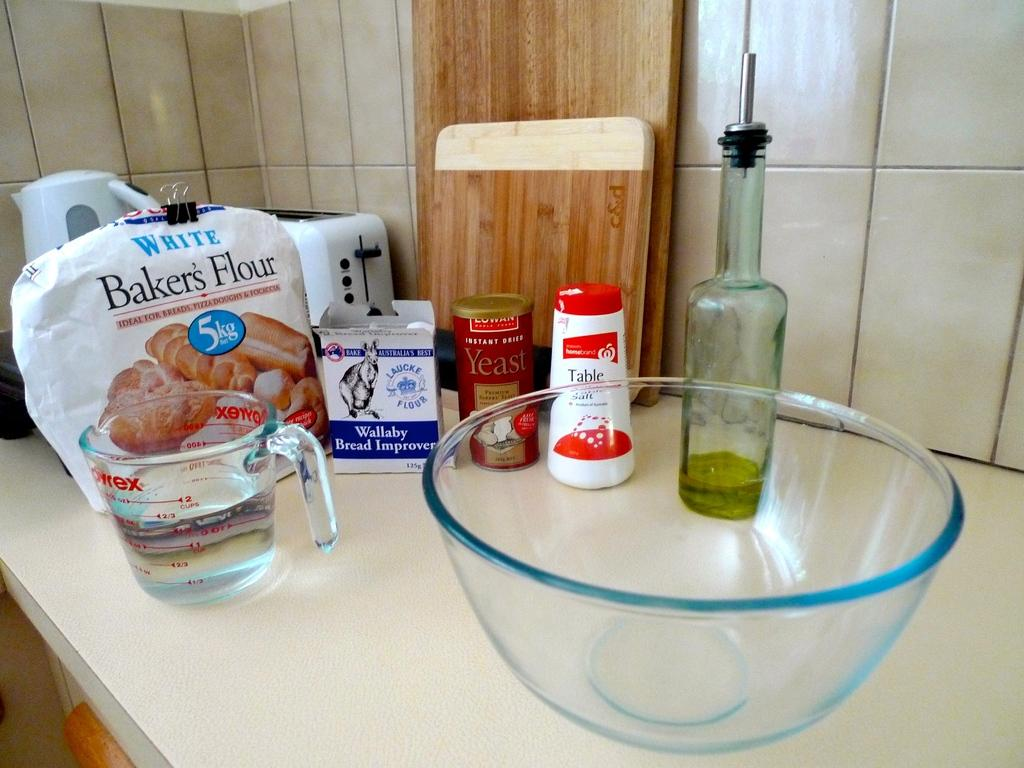<image>
Write a terse but informative summary of the picture. A 5 kg sack of flour is on a counter with baking supplies. 